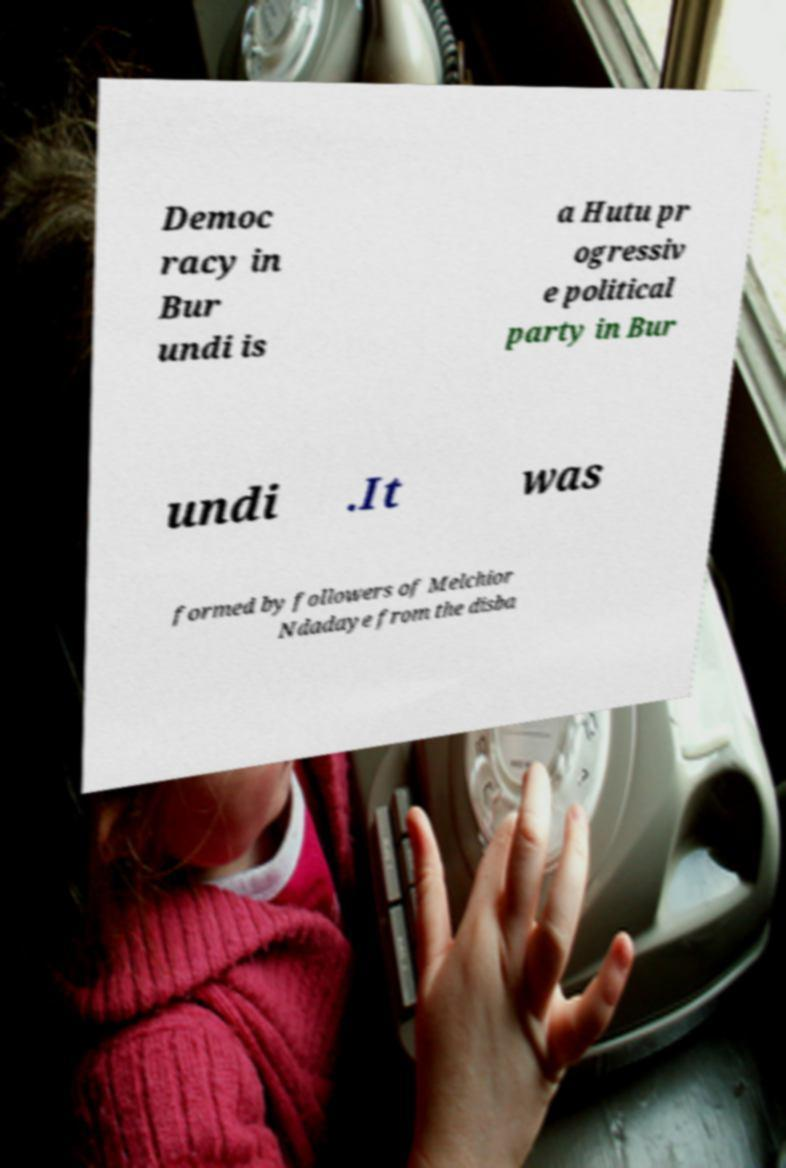Could you extract and type out the text from this image? Democ racy in Bur undi is a Hutu pr ogressiv e political party in Bur undi .It was formed by followers of Melchior Ndadaye from the disba 